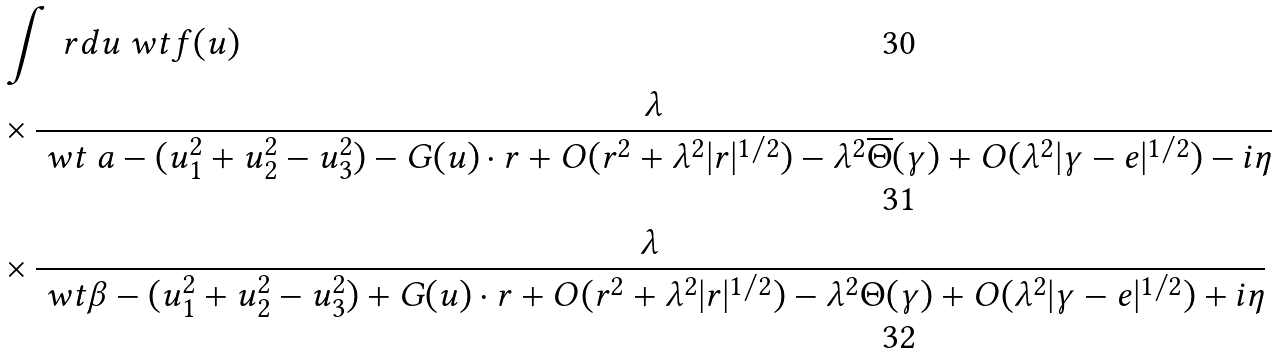Convert formula to latex. <formula><loc_0><loc_0><loc_500><loc_500>& \int \ r d u { \ w t f ( u ) } \\ & \times \frac { \lambda } { \ w t \ a - ( u _ { 1 } ^ { 2 } + u _ { 2 } ^ { 2 } - u _ { 3 } ^ { 2 } ) - G ( u ) \cdot r + O ( r ^ { 2 } + \lambda ^ { 2 } | r | ^ { 1 / 2 } ) - \lambda ^ { 2 } \overline { \Theta } ( \gamma ) + O ( \lambda ^ { 2 } | \gamma - e | ^ { 1 / 2 } ) - i \eta } \\ & \times \frac { \lambda } { \ w t \beta - ( u _ { 1 } ^ { 2 } + u _ { 2 } ^ { 2 } - u _ { 3 } ^ { 2 } ) + G ( u ) \cdot r + O ( r ^ { 2 } + \lambda ^ { 2 } | r | ^ { 1 / 2 } ) - \lambda ^ { 2 } { \Theta } ( \gamma ) + O ( \lambda ^ { 2 } | \gamma - e | ^ { 1 / 2 } ) + i \eta }</formula> 